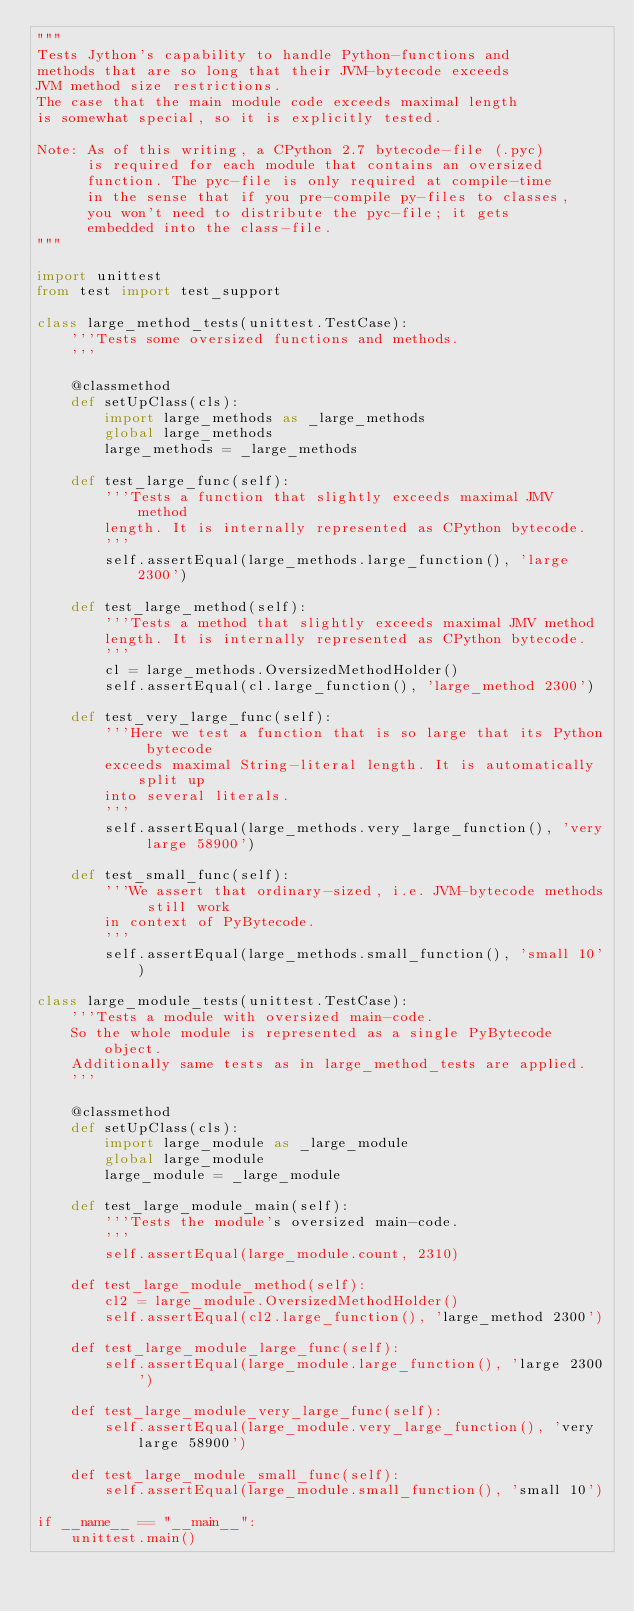Convert code to text. <code><loc_0><loc_0><loc_500><loc_500><_Python_>"""
Tests Jython's capability to handle Python-functions and
methods that are so long that their JVM-bytecode exceeds
JVM method size restrictions.
The case that the main module code exceeds maximal length
is somewhat special, so it is explicitly tested.

Note: As of this writing, a CPython 2.7 bytecode-file (.pyc)
      is required for each module that contains an oversized
      function. The pyc-file is only required at compile-time
      in the sense that if you pre-compile py-files to classes,
      you won't need to distribute the pyc-file; it gets
      embedded into the class-file.
"""

import unittest
from test import test_support

class large_method_tests(unittest.TestCase):
    '''Tests some oversized functions and methods.
    '''

    @classmethod
    def setUpClass(cls):
        import large_methods as _large_methods
        global large_methods
        large_methods = _large_methods

    def test_large_func(self):
        '''Tests a function that slightly exceeds maximal JMV method
        length. It is internally represented as CPython bytecode.
        '''
        self.assertEqual(large_methods.large_function(), 'large 2300')

    def test_large_method(self):
        '''Tests a method that slightly exceeds maximal JMV method
        length. It is internally represented as CPython bytecode.
        '''
        cl = large_methods.OversizedMethodHolder()
        self.assertEqual(cl.large_function(), 'large_method 2300')

    def test_very_large_func(self):
        '''Here we test a function that is so large that its Python bytecode
        exceeds maximal String-literal length. It is automatically split up
        into several literals.
        '''
        self.assertEqual(large_methods.very_large_function(), 'very large 58900')

    def test_small_func(self):
        '''We assert that ordinary-sized, i.e. JVM-bytecode methods still work
        in context of PyBytecode.
        '''
        self.assertEqual(large_methods.small_function(), 'small 10')

class large_module_tests(unittest.TestCase):
    '''Tests a module with oversized main-code.
    So the whole module is represented as a single PyBytecode object.
    Additionally same tests as in large_method_tests are applied.
    '''

    @classmethod
    def setUpClass(cls):
        import large_module as _large_module
        global large_module
        large_module = _large_module

    def test_large_module_main(self):
        '''Tests the module's oversized main-code.
        '''
        self.assertEqual(large_module.count, 2310)

    def test_large_module_method(self):
        cl2 = large_module.OversizedMethodHolder()
        self.assertEqual(cl2.large_function(), 'large_method 2300')

    def test_large_module_large_func(self):
        self.assertEqual(large_module.large_function(), 'large 2300')

    def test_large_module_very_large_func(self):
        self.assertEqual(large_module.very_large_function(), 'very large 58900')

    def test_large_module_small_func(self):
        self.assertEqual(large_module.small_function(), 'small 10')

if __name__ == "__main__":
    unittest.main()

</code> 